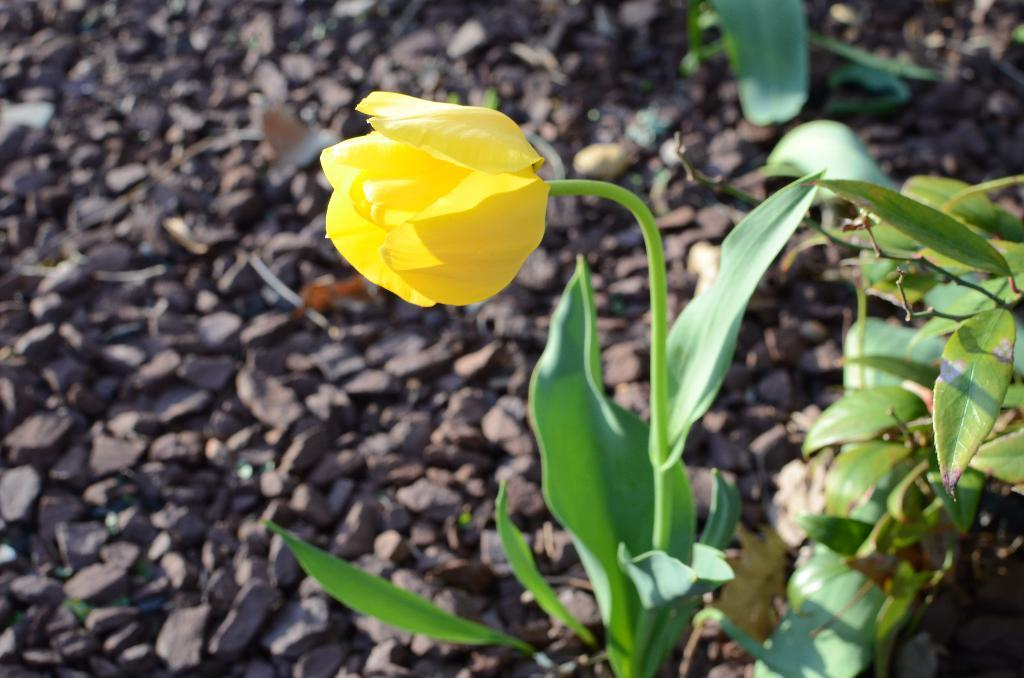What type of flower is on the plant in the image? There is a yellow flower on a plant in the image. What color are the leaves on the right side of the plant? The leaves on the right side of the plant are green. What can be seen on the ground in the image? There are stones visible on a path in the image. Can you help me find the sweater that was left on the playground in the image? There is no playground or sweater present in the image; it features a plant with a yellow flower and green leaves, as well as a path with stones. 